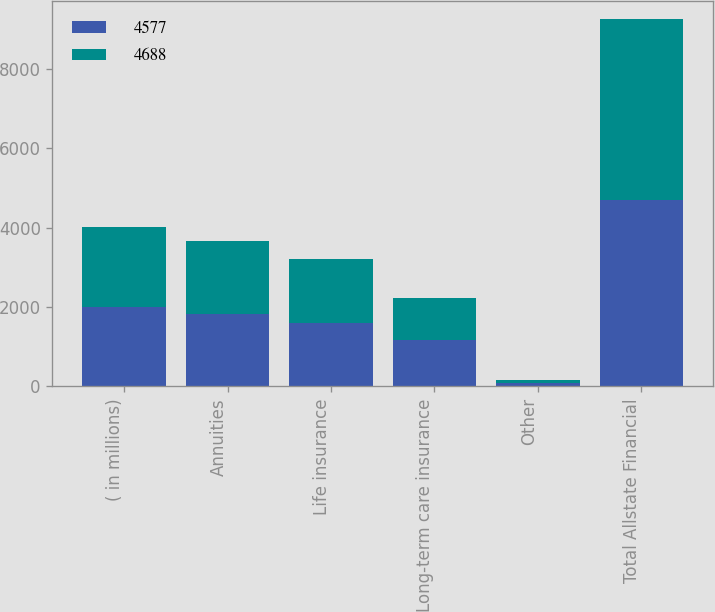Convert chart to OTSL. <chart><loc_0><loc_0><loc_500><loc_500><stacked_bar_chart><ecel><fcel>( in millions)<fcel>Annuities<fcel>Life insurance<fcel>Long-term care insurance<fcel>Other<fcel>Total Allstate Financial<nl><fcel>4577<fcel>2012<fcel>1831<fcel>1609<fcel>1163<fcel>85<fcel>4688<nl><fcel>4688<fcel>2011<fcel>1827<fcel>1600<fcel>1063<fcel>87<fcel>4577<nl></chart> 